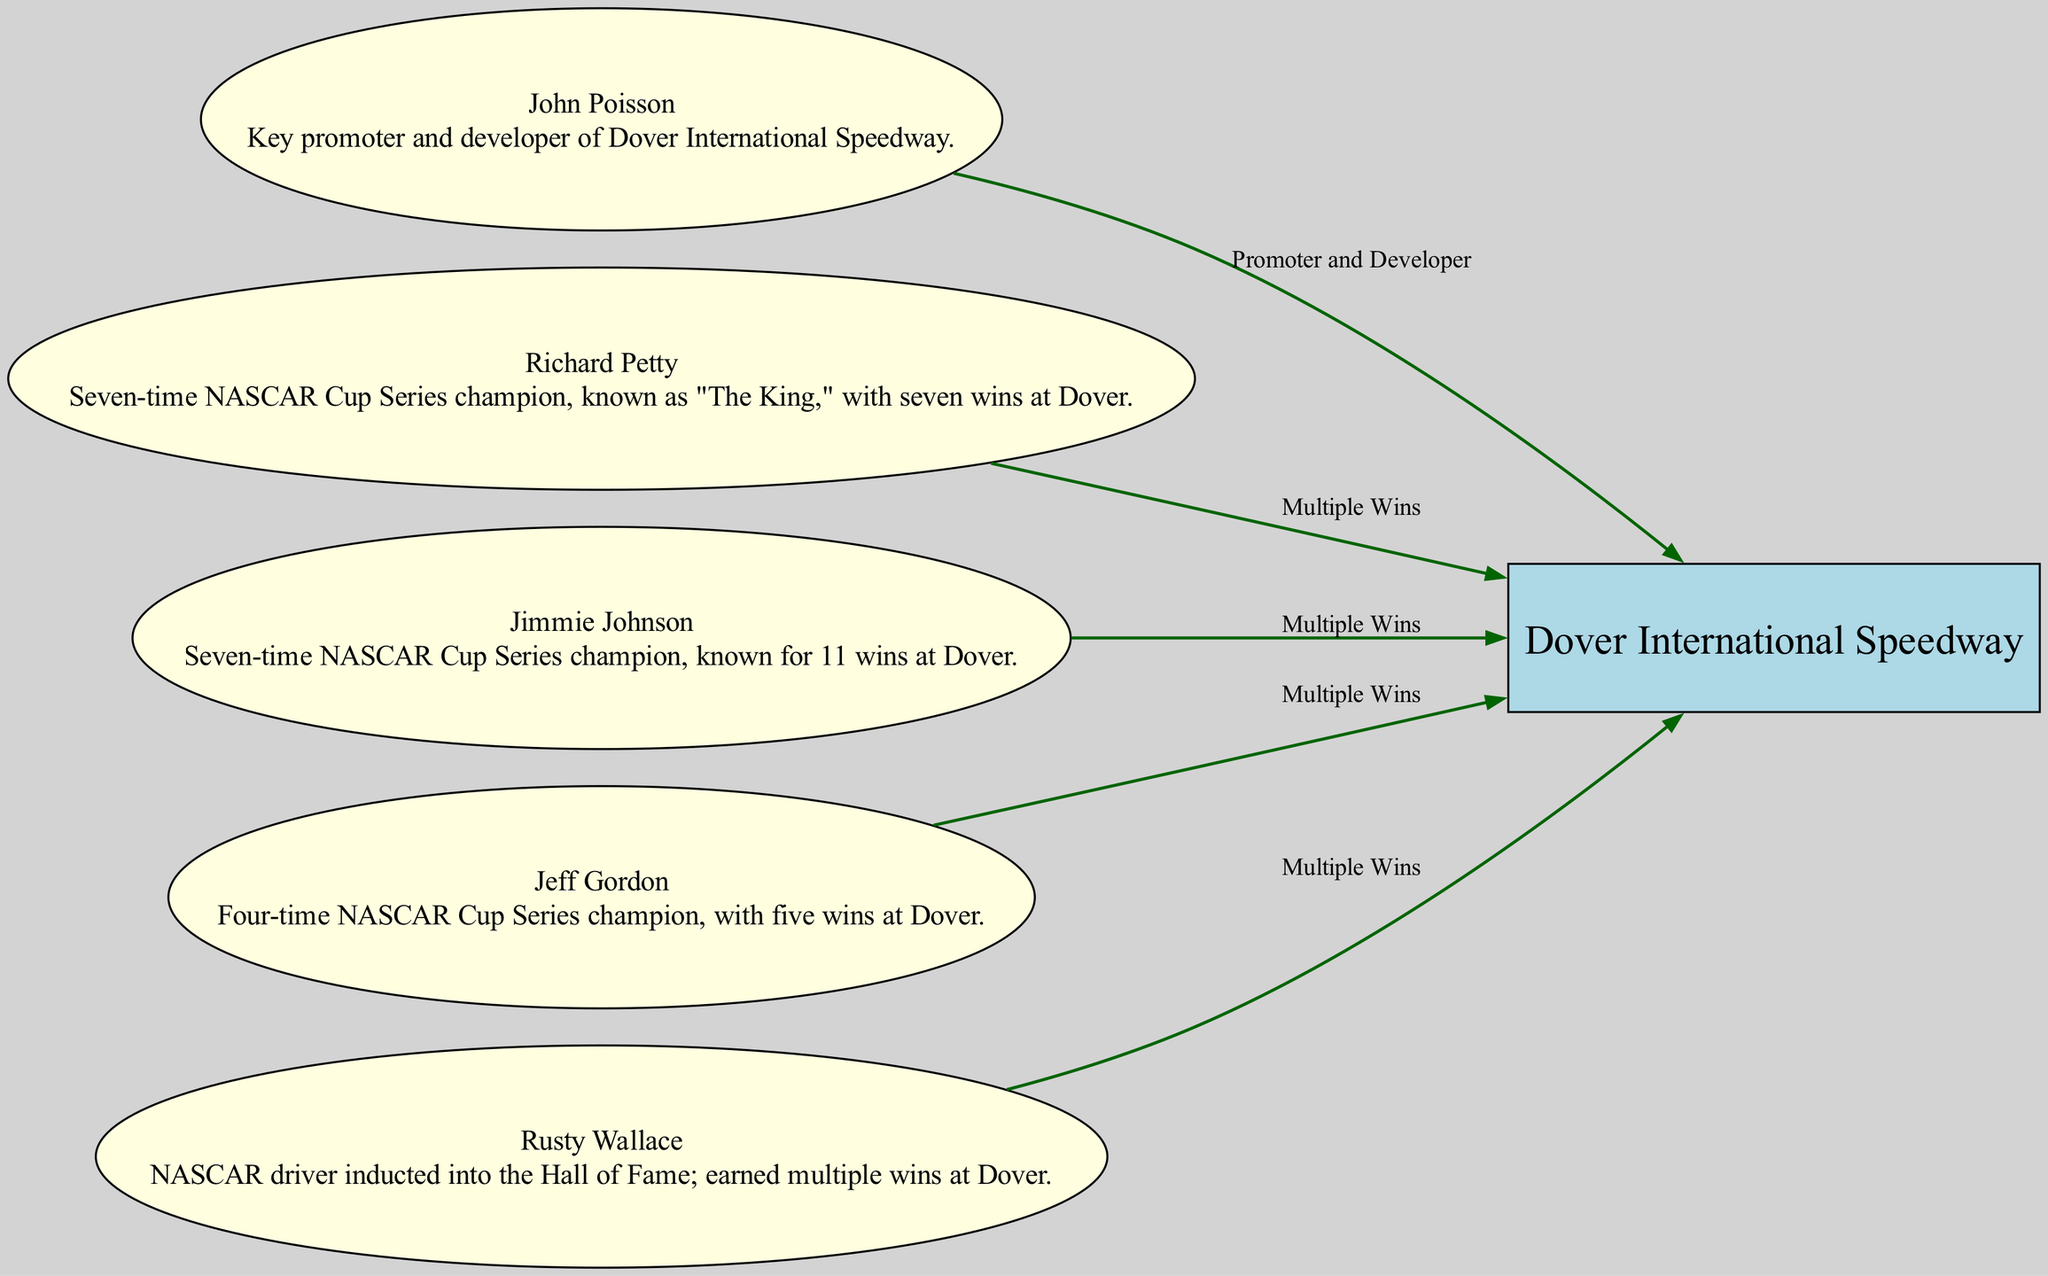What is the title of the diagram? The title of the diagram is explicitly mentioned at the beginning of the data provided. It is labeled as "Key Figures in Dover's Racing History."
Answer: Key Figures in Dover's Racing History How many key figures are represented in the diagram? The diagram lists six nodes in total: Dover International Speedway, John Poisson, Richard Petty, Jimmie Johnson, Jeff Gordon, and Rusty Wallace. Therefore, the number of key figures is five, excluding the speedway itself.
Answer: 5 Who is described as "The King"? The node for Richard Petty includes a description stating he is known as "The King."
Answer: Richard Petty What is the relationship between John Poisson and Dover International Speedway? The relationship from John Poisson to Dover International Speedway is labeled as "Promoter and Developer," indicating Poisson's contribution to the speedway.
Answer: Promoter and Developer Which driver has the most wins at Dover? The diagram indicates that Jimmie Johnson is known for 11 wins at Dover, which is more than any other driver mentioned in the diagram.
Answer: Jimmie Johnson Name one driver who has multiple wins at Dover. The relationships show that Richard Petty, Jimmie Johnson, Jeff Gordon, and Rusty Wallace all have multiple wins at Dover. Therefore, any of these names can be valid answers.
Answer: Richard Petty What is the total number of relationships depicted in the diagram? There are five relationships represented where key figures are linked to the Dover International Speedway. Counting them, there are precisely five edges connecting the nodes to the speedway.
Answer: 5 Which figure is a NASCAR Hall of Fame inductee? Rusty Wallace is the figure noted as a NASCAR driver inducted into the Hall of Fame in his description.
Answer: Rusty Wallace What type of node represents Dover International Speedway? The node for Dover International Speedway is depicted as a box with a filled color style, differentiating it from the other nodes.
Answer: Box 